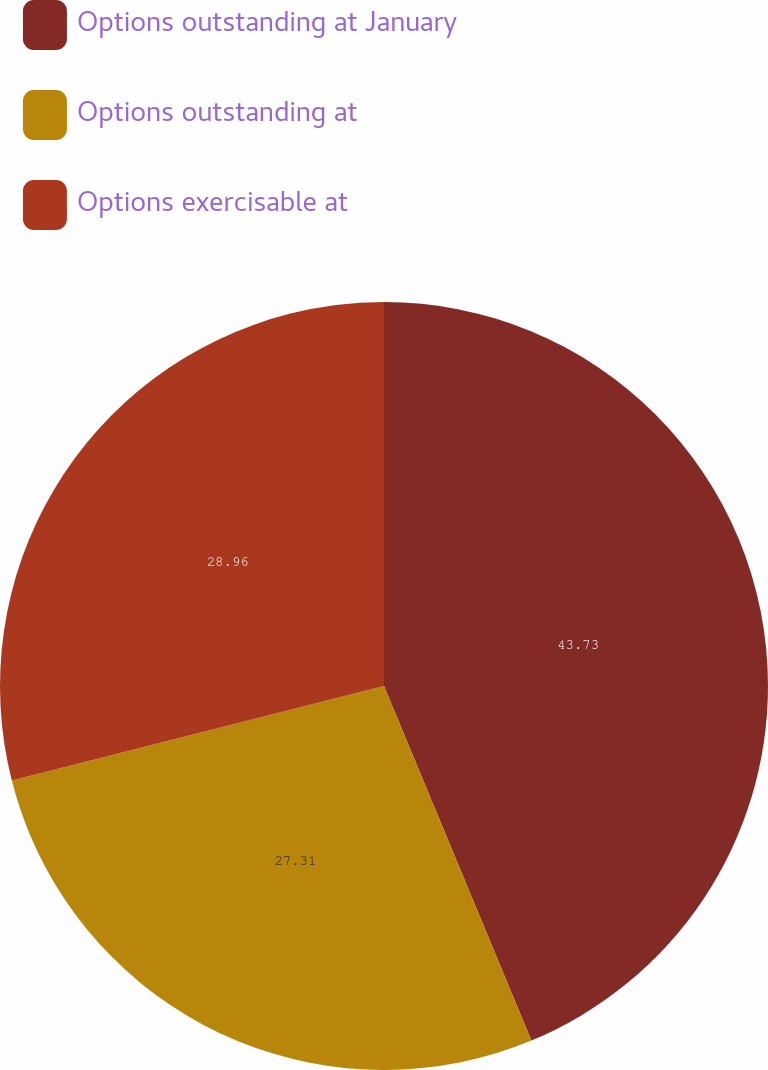Convert chart to OTSL. <chart><loc_0><loc_0><loc_500><loc_500><pie_chart><fcel>Options outstanding at January<fcel>Options outstanding at<fcel>Options exercisable at<nl><fcel>43.73%<fcel>27.31%<fcel>28.96%<nl></chart> 